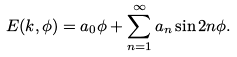<formula> <loc_0><loc_0><loc_500><loc_500>E ( k , \phi ) = a _ { 0 } \phi + \sum _ { n = 1 } ^ { \infty } a _ { n } \sin 2 n \phi .</formula> 